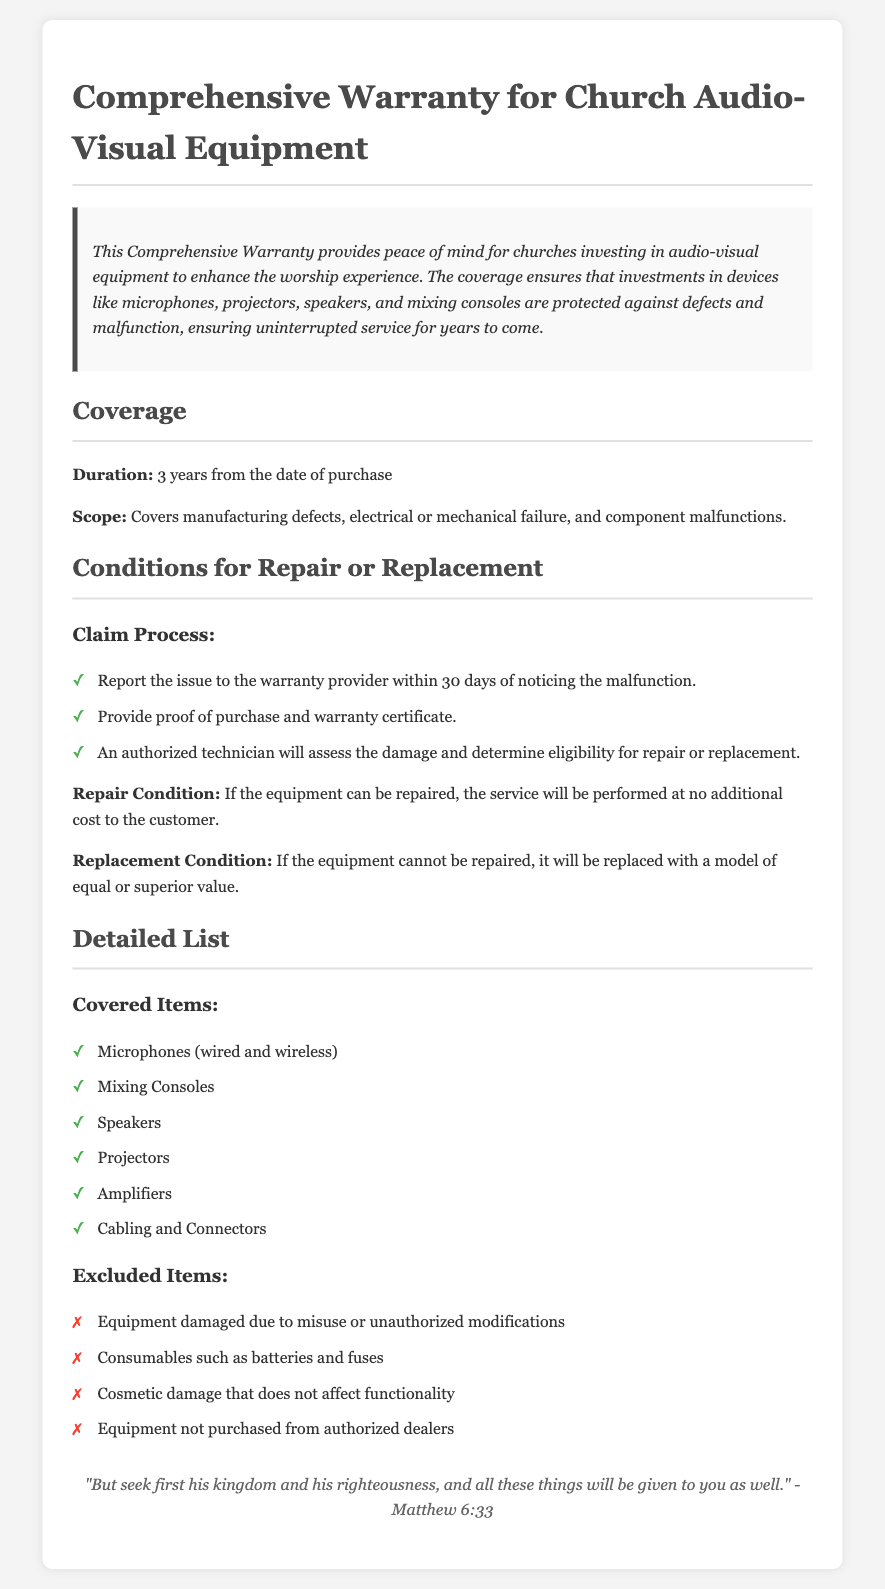what is the duration of the warranty? The document states that the warranty lasts for 3 years from the date of purchase.
Answer: 3 years what kind of damages are excluded? The warranty lists specific items not covered, such as equipment damaged due to misuse.
Answer: Misuse when must an issue be reported to the warranty provider? The document indicates that the issue must be reported within 30 days of noticing the malfunction.
Answer: 30 days what equipment is covered by the warranty? The warranty mentions several items, including microphones and mixing consoles, as covered.
Answer: Microphones what happens if the equipment cannot be repaired? The document specifies that if the equipment cannot be repaired, it will be replaced with a model of equal or superior value.
Answer: Replaced which conditions must be met for repair services? The warranty outlines that proof of purchase and a warranty certificate must be provided to access repair services.
Answer: Proof of purchase what is the process for claiming warranty service? The document details a claim process that starts with reporting the issue and providing necessary documentation.
Answer: Report issue what is the scope of the coverage? The warranty covers manufacturing defects, electrical or mechanical failure, and component malfunctions.
Answer: Defects how does the document conclude? The document concludes with a Bible verse that emphasizes prioritizing righteousness and God's kingdom.
Answer: Matthew 6:33 